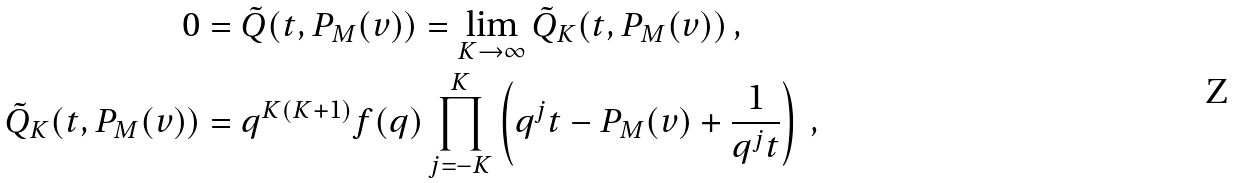<formula> <loc_0><loc_0><loc_500><loc_500>0 & = \tilde { Q } ( t , P _ { M } ( v ) ) = \lim _ { K \to \infty } \tilde { Q } _ { K } ( t , P _ { M } ( v ) ) \, , \\ \tilde { Q } _ { K } ( t , P _ { M } ( v ) ) & = q ^ { K ( K + 1 ) } f ( q ) \prod _ { j = - K } ^ { K } \left ( q ^ { j } t - P _ { M } ( v ) + \frac { 1 } { q ^ { j } t } \right ) \, ,</formula> 